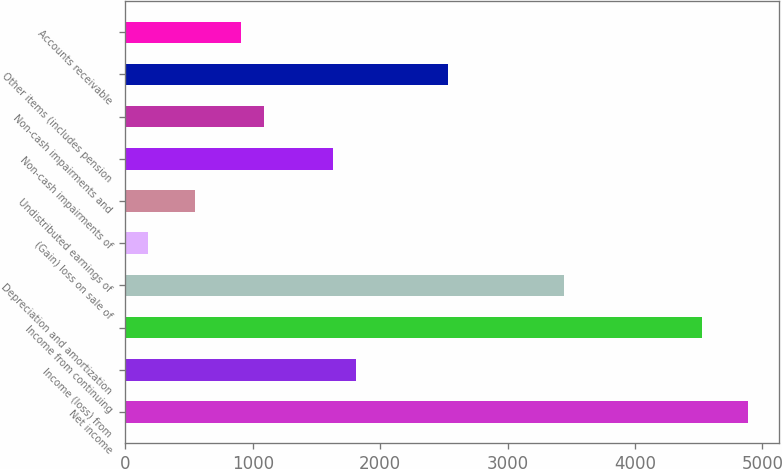Convert chart. <chart><loc_0><loc_0><loc_500><loc_500><bar_chart><fcel>Net income<fcel>Income (loss) from<fcel>Income from continuing<fcel>Depreciation and amortization<fcel>(Gain) loss on sale of<fcel>Undistributed earnings of<fcel>Non-cash impairments of<fcel>Non-cash impairments and<fcel>Other items (includes pension<fcel>Accounts receivable<nl><fcel>4887.7<fcel>1810.7<fcel>4525.7<fcel>3439.7<fcel>181.7<fcel>543.7<fcel>1629.7<fcel>1086.7<fcel>2534.7<fcel>905.7<nl></chart> 